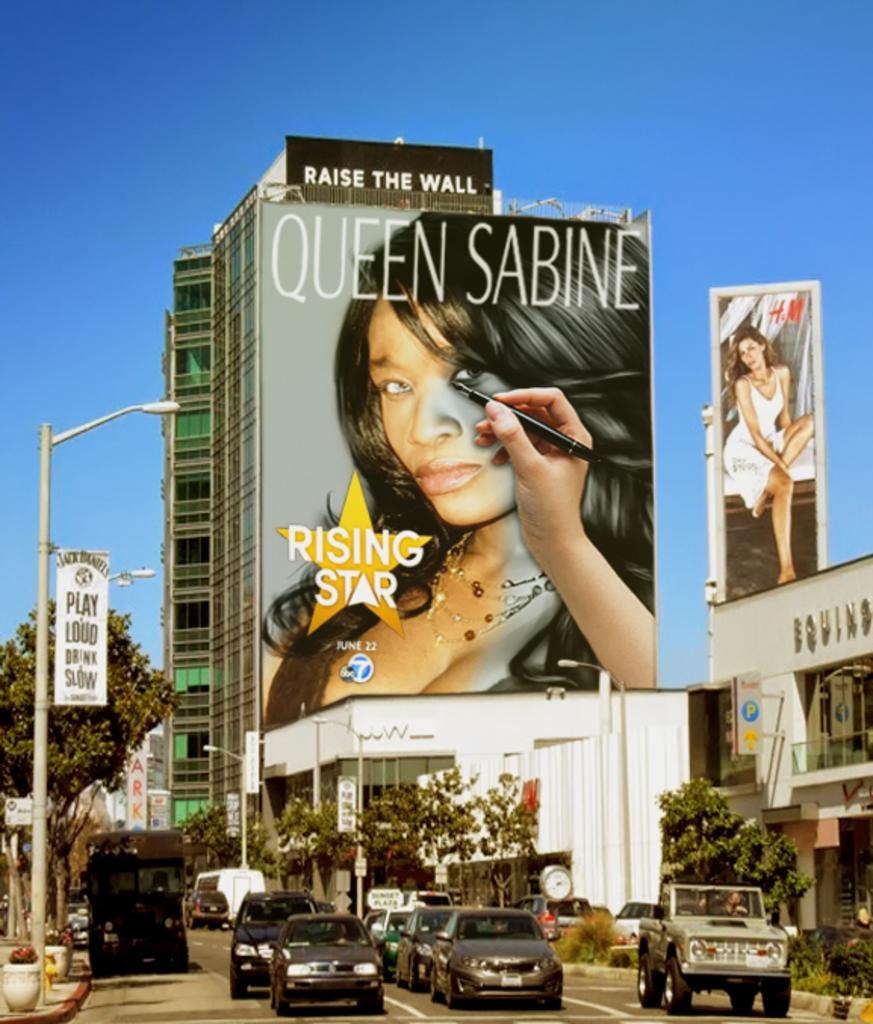Who is the rising star on the billboard?
Provide a short and direct response. Queen sabine. Raise the what?
Give a very brief answer. Wall. 